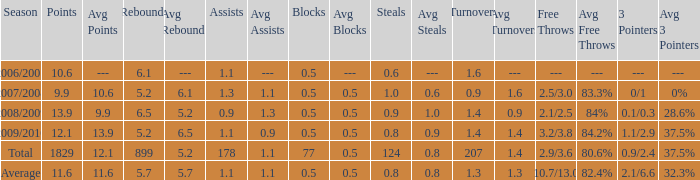Could you parse the entire table as a dict? {'header': ['Season', 'Points', 'Avg Points', 'Rebounds', 'Avg Rebounds', 'Assists', 'Avg Assists', 'Blocks', 'Avg Blocks', 'Steals', 'Avg Steals', 'Turnovers', 'Avg Turnovers', 'Free Throws', 'Avg Free Throws', '3 Pointers', 'Avg 3 Pointers '], 'rows': [['2006/2007', '10.6', '---', '6.1', '---', '1.1', '---', '0.5', '---', '0.6', '---', '1.6', '---', '---', '---', '---', '--- '], ['2007/2008', '9.9', '10.6', '5.2', '6.1', '1.3', '1.1', '0.5', '0.5', '1.0', '0.6', '0.9', '1.6', '2.5/3.0', '83.3%', '0/1', '0%'], ['2008/2009', '13.9', '9.9', '6.5', '5.2', '0.9', '1.3', '0.5', '0.5', '0.9', '1.0', '1.4', '0.9', '2.1/2.5', '84%', '0.1/0.3', '28.6%'], ['2009/2010', '12.1', '13.9', '5.2', '6.5', '1.1', '0.9', '0.5', '0.5', '0.8', '0.9', '1.4', '1.4', '3.2/3.8', '84.2%', '1.1/2.9', '37.5%'], ['Total', '1829', '12.1', '899', '5.2', '178', '1.1', '77', '0.5', '124', '0.8', '207', '1.4', '2.9/3.6', '80.6%', '0.9/2.4', '37.5%'], ['Average', '11.6', '11.6', '5.7', '5.7', '1.1', '1.1', '0.5', '0.5', '0.8', '0.8', '1.3', '1.3', '10.7/13.0', '82.4%', '2.1/6.6', '32.3%']]} How many blocks are there when the rebounds are fewer than 5.2? 0.0. 